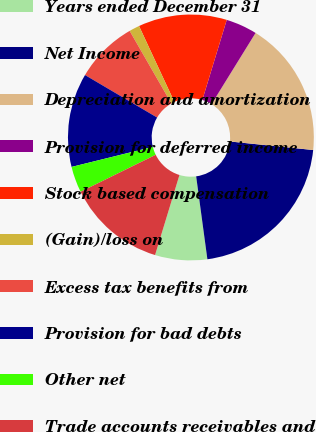Convert chart. <chart><loc_0><loc_0><loc_500><loc_500><pie_chart><fcel>Years ended December 31<fcel>Net Income<fcel>Depreciation and amortization<fcel>Provision for deferred income<fcel>Stock based compensation<fcel>(Gain)/loss on<fcel>Excess tax benefits from<fcel>Provision for bad debts<fcel>Other net<fcel>Trade accounts receivables and<nl><fcel>6.85%<fcel>21.23%<fcel>17.81%<fcel>4.11%<fcel>11.64%<fcel>1.37%<fcel>8.22%<fcel>12.33%<fcel>3.43%<fcel>13.01%<nl></chart> 